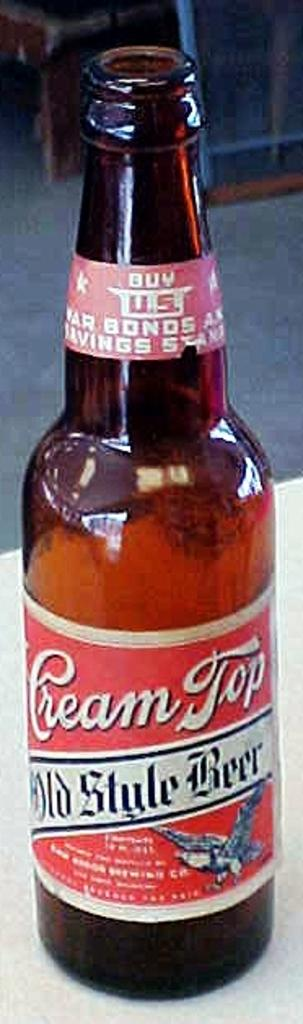What object is present in the image? There is a glass bottle in the image. What type of religious symbol can be seen on the glass bottle in the image? There is no religious symbol present on the glass bottle in the image. How many sheep are visible in the image? There are no sheep present in the image. What type of worm can be seen crawling on the glass bottle in the image? There are no worms present in the image. 